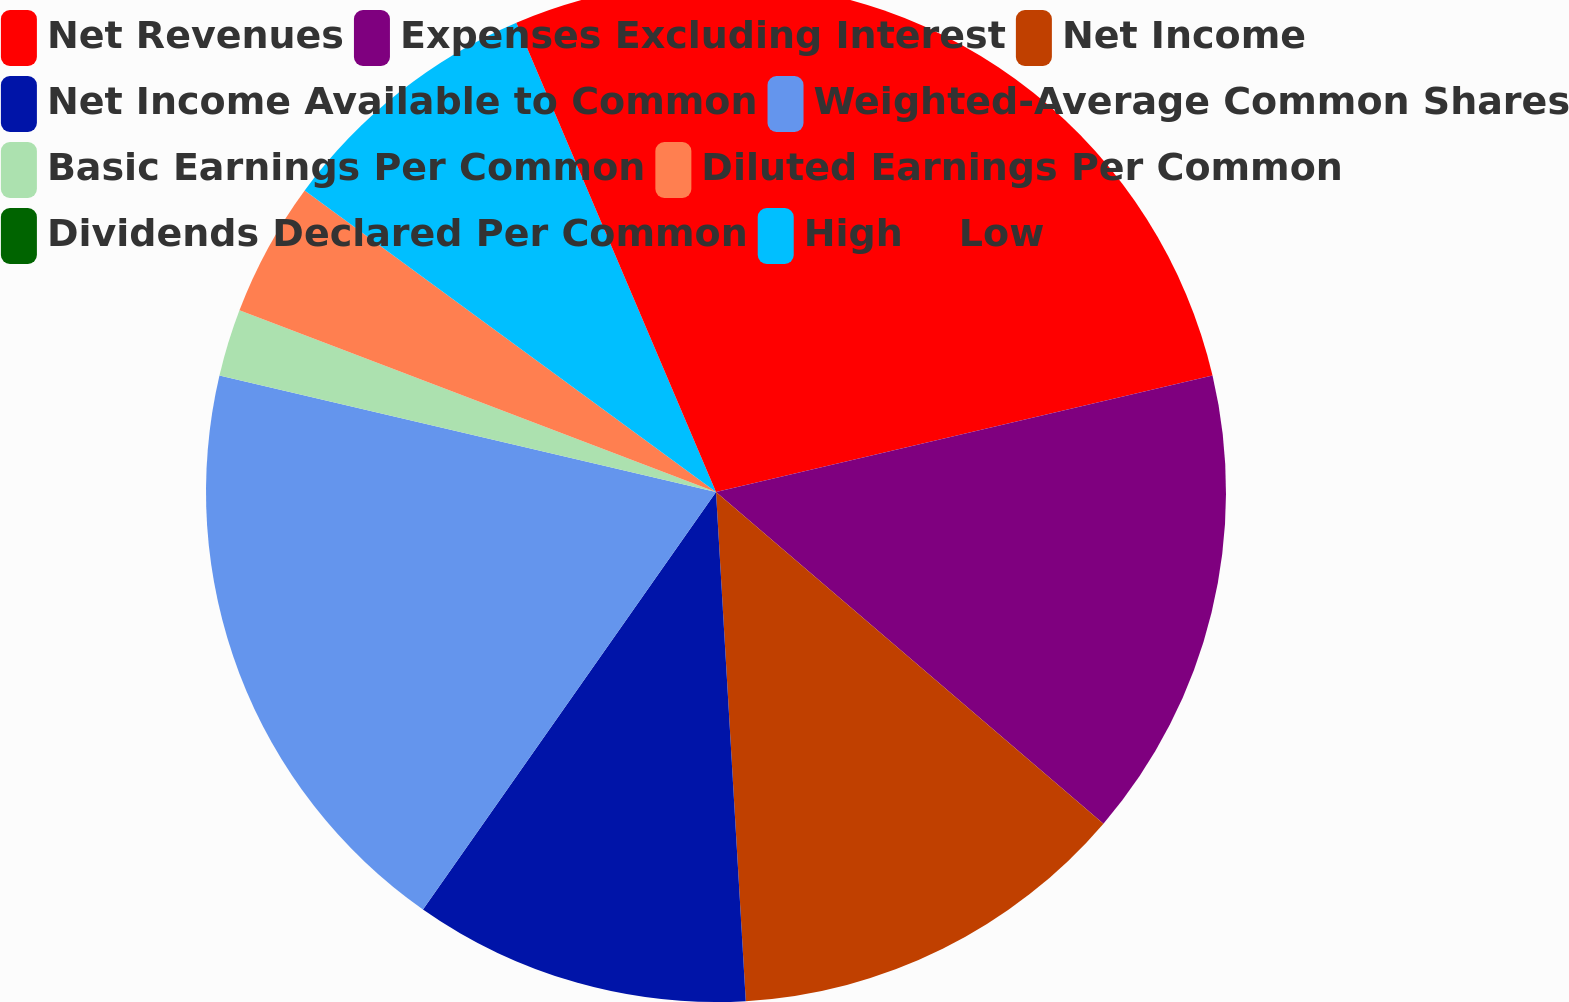<chart> <loc_0><loc_0><loc_500><loc_500><pie_chart><fcel>Net Revenues<fcel>Expenses Excluding Interest<fcel>Net Income<fcel>Net Income Available to Common<fcel>Weighted-Average Common Shares<fcel>Basic Earnings Per Common<fcel>Diluted Earnings Per Common<fcel>Dividends Declared Per Common<fcel>High<fcel>Low<nl><fcel>21.33%<fcel>14.93%<fcel>12.8%<fcel>10.67%<fcel>18.92%<fcel>2.13%<fcel>4.27%<fcel>0.0%<fcel>8.53%<fcel>6.4%<nl></chart> 